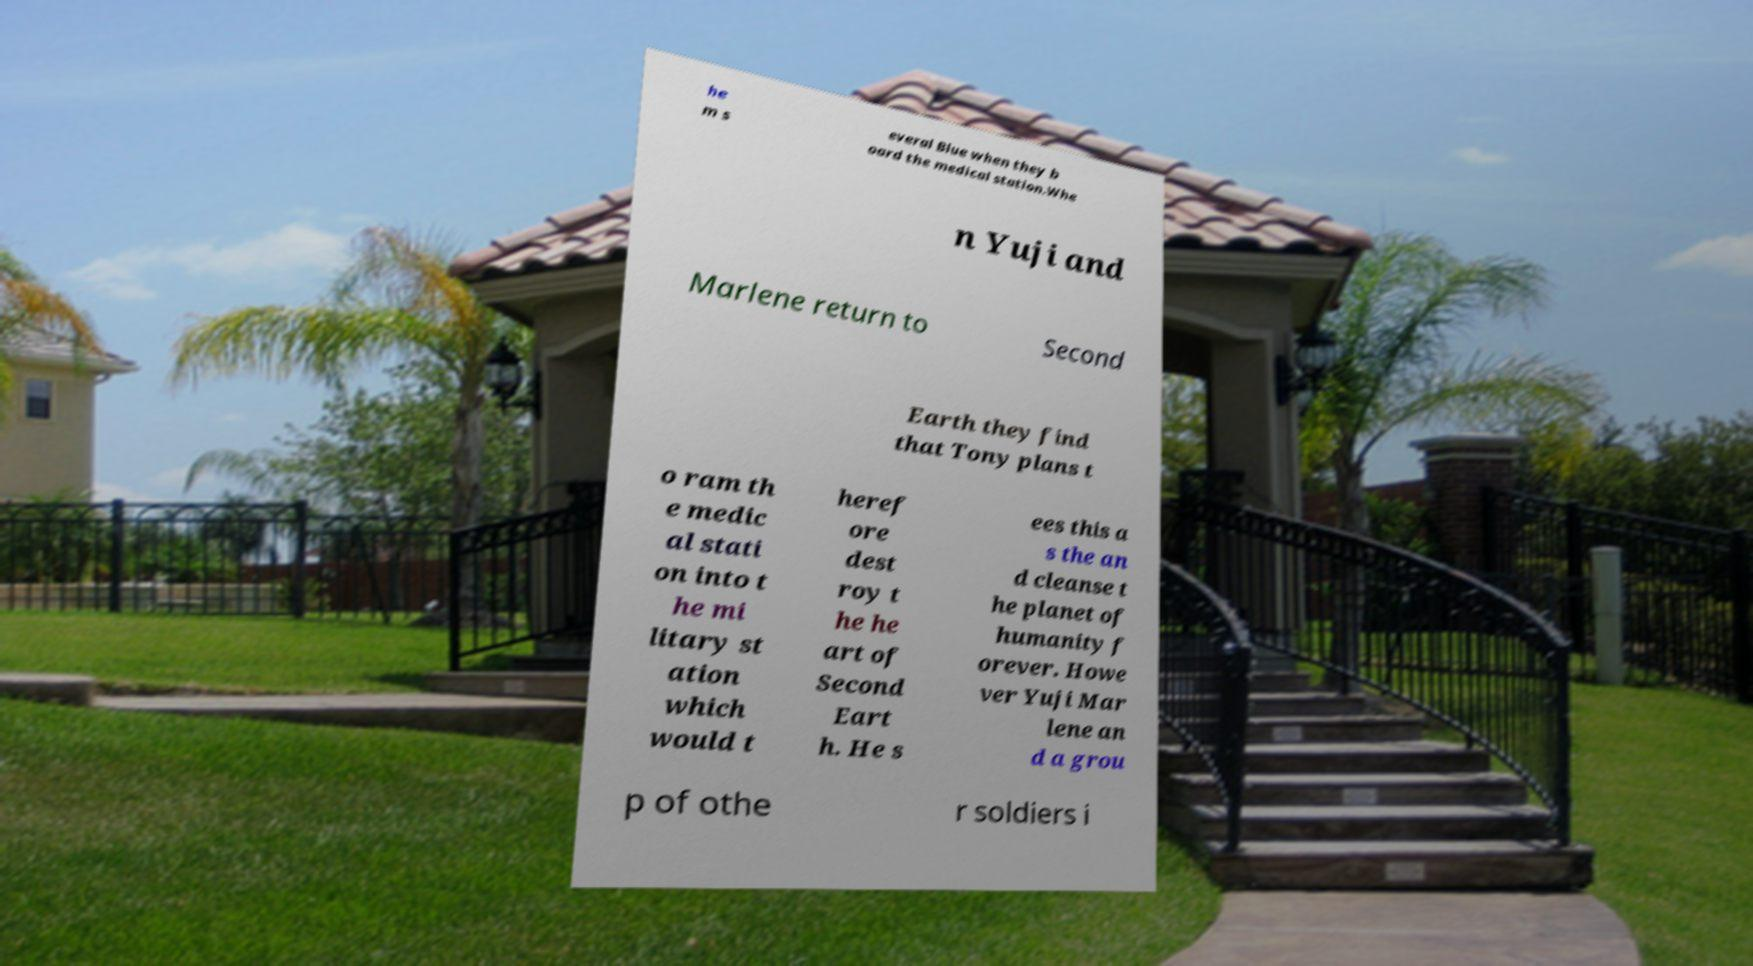Can you read and provide the text displayed in the image?This photo seems to have some interesting text. Can you extract and type it out for me? he m s everal Blue when they b oard the medical station.Whe n Yuji and Marlene return to Second Earth they find that Tony plans t o ram th e medic al stati on into t he mi litary st ation which would t heref ore dest roy t he he art of Second Eart h. He s ees this a s the an d cleanse t he planet of humanity f orever. Howe ver Yuji Mar lene an d a grou p of othe r soldiers i 